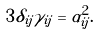Convert formula to latex. <formula><loc_0><loc_0><loc_500><loc_500>3 \delta _ { i j } \gamma _ { i j } = \alpha _ { i j } ^ { 2 } .</formula> 